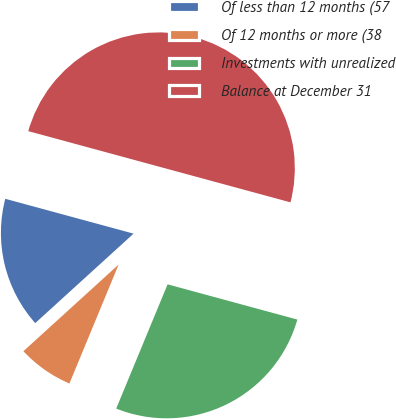<chart> <loc_0><loc_0><loc_500><loc_500><pie_chart><fcel>Of less than 12 months (57<fcel>Of 12 months or more (38<fcel>Investments with unrealized<fcel>Balance at December 31<nl><fcel>15.97%<fcel>7.01%<fcel>27.02%<fcel>50.0%<nl></chart> 